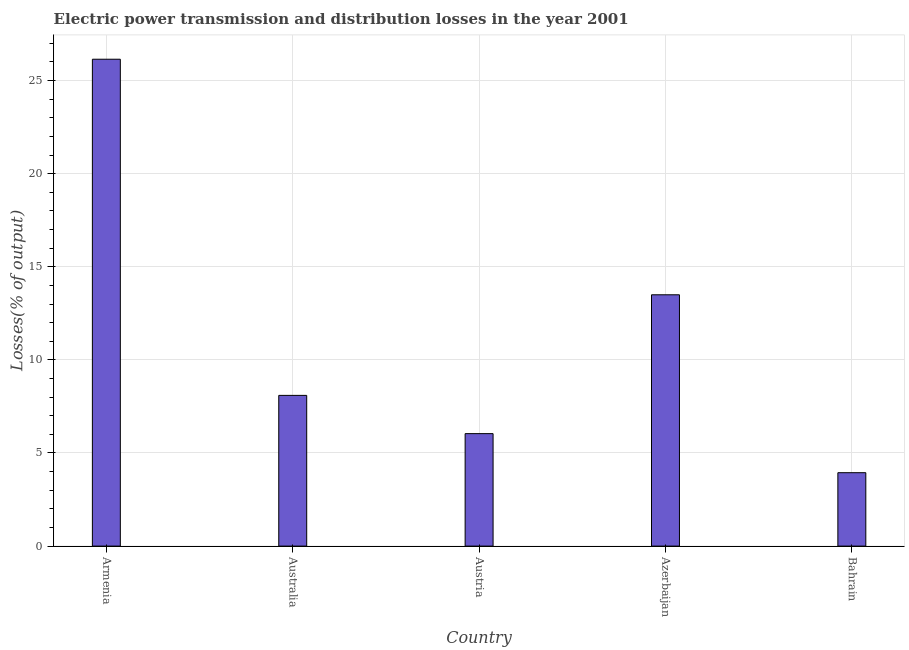Does the graph contain grids?
Ensure brevity in your answer.  Yes. What is the title of the graph?
Ensure brevity in your answer.  Electric power transmission and distribution losses in the year 2001. What is the label or title of the Y-axis?
Offer a very short reply. Losses(% of output). What is the electric power transmission and distribution losses in Armenia?
Your response must be concise. 26.14. Across all countries, what is the maximum electric power transmission and distribution losses?
Offer a terse response. 26.14. Across all countries, what is the minimum electric power transmission and distribution losses?
Your answer should be compact. 3.94. In which country was the electric power transmission and distribution losses maximum?
Offer a terse response. Armenia. In which country was the electric power transmission and distribution losses minimum?
Offer a terse response. Bahrain. What is the sum of the electric power transmission and distribution losses?
Your answer should be very brief. 57.71. What is the difference between the electric power transmission and distribution losses in Azerbaijan and Bahrain?
Your answer should be compact. 9.55. What is the average electric power transmission and distribution losses per country?
Provide a succinct answer. 11.54. What is the median electric power transmission and distribution losses?
Ensure brevity in your answer.  8.09. In how many countries, is the electric power transmission and distribution losses greater than 2 %?
Keep it short and to the point. 5. What is the ratio of the electric power transmission and distribution losses in Armenia to that in Austria?
Your answer should be compact. 4.33. Is the electric power transmission and distribution losses in Armenia less than that in Bahrain?
Offer a terse response. No. Is the difference between the electric power transmission and distribution losses in Armenia and Azerbaijan greater than the difference between any two countries?
Offer a very short reply. No. What is the difference between the highest and the second highest electric power transmission and distribution losses?
Your answer should be very brief. 12.65. What is the difference between the highest and the lowest electric power transmission and distribution losses?
Offer a very short reply. 22.2. How many bars are there?
Offer a terse response. 5. What is the Losses(% of output) of Armenia?
Offer a terse response. 26.14. What is the Losses(% of output) of Australia?
Provide a short and direct response. 8.09. What is the Losses(% of output) in Austria?
Give a very brief answer. 6.04. What is the Losses(% of output) of Azerbaijan?
Your answer should be compact. 13.49. What is the Losses(% of output) in Bahrain?
Make the answer very short. 3.94. What is the difference between the Losses(% of output) in Armenia and Australia?
Offer a terse response. 18.05. What is the difference between the Losses(% of output) in Armenia and Austria?
Provide a succinct answer. 20.11. What is the difference between the Losses(% of output) in Armenia and Azerbaijan?
Your answer should be compact. 12.65. What is the difference between the Losses(% of output) in Armenia and Bahrain?
Keep it short and to the point. 22.2. What is the difference between the Losses(% of output) in Australia and Austria?
Your answer should be compact. 2.05. What is the difference between the Losses(% of output) in Australia and Azerbaijan?
Make the answer very short. -5.4. What is the difference between the Losses(% of output) in Australia and Bahrain?
Provide a short and direct response. 4.15. What is the difference between the Losses(% of output) in Austria and Azerbaijan?
Your answer should be very brief. -7.46. What is the difference between the Losses(% of output) in Austria and Bahrain?
Ensure brevity in your answer.  2.1. What is the difference between the Losses(% of output) in Azerbaijan and Bahrain?
Give a very brief answer. 9.55. What is the ratio of the Losses(% of output) in Armenia to that in Australia?
Offer a terse response. 3.23. What is the ratio of the Losses(% of output) in Armenia to that in Austria?
Offer a terse response. 4.33. What is the ratio of the Losses(% of output) in Armenia to that in Azerbaijan?
Ensure brevity in your answer.  1.94. What is the ratio of the Losses(% of output) in Armenia to that in Bahrain?
Keep it short and to the point. 6.63. What is the ratio of the Losses(% of output) in Australia to that in Austria?
Ensure brevity in your answer.  1.34. What is the ratio of the Losses(% of output) in Australia to that in Bahrain?
Keep it short and to the point. 2.05. What is the ratio of the Losses(% of output) in Austria to that in Azerbaijan?
Offer a terse response. 0.45. What is the ratio of the Losses(% of output) in Austria to that in Bahrain?
Your answer should be very brief. 1.53. What is the ratio of the Losses(% of output) in Azerbaijan to that in Bahrain?
Make the answer very short. 3.42. 